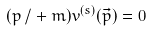Convert formula to latex. <formula><loc_0><loc_0><loc_500><loc_500>( { p \, / } + m ) v ^ { ( s ) } ( { \vec { p } } ) = 0</formula> 